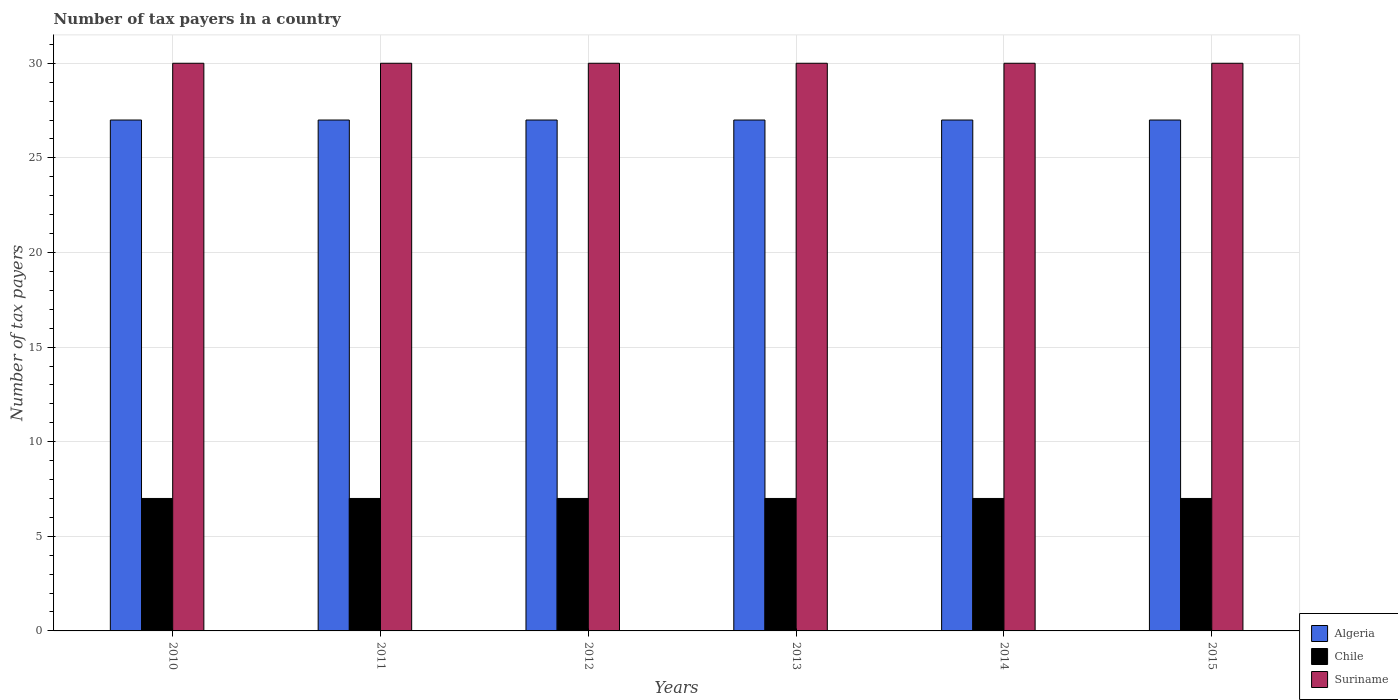In how many cases, is the number of bars for a given year not equal to the number of legend labels?
Ensure brevity in your answer.  0. What is the number of tax payers in in Chile in 2014?
Your answer should be compact. 7. Across all years, what is the maximum number of tax payers in in Chile?
Keep it short and to the point. 7. Across all years, what is the minimum number of tax payers in in Suriname?
Offer a terse response. 30. In which year was the number of tax payers in in Suriname minimum?
Your answer should be very brief. 2010. What is the total number of tax payers in in Chile in the graph?
Give a very brief answer. 42. What is the difference between the number of tax payers in in Chile in 2011 and that in 2014?
Give a very brief answer. 0. What is the difference between the number of tax payers in in Suriname in 2015 and the number of tax payers in in Algeria in 2013?
Provide a succinct answer. 3. In the year 2010, what is the difference between the number of tax payers in in Suriname and number of tax payers in in Chile?
Provide a short and direct response. 23. In how many years, is the number of tax payers in in Algeria greater than 26?
Offer a very short reply. 6. Is the difference between the number of tax payers in in Suriname in 2014 and 2015 greater than the difference between the number of tax payers in in Chile in 2014 and 2015?
Your answer should be compact. No. What is the difference between the highest and the second highest number of tax payers in in Suriname?
Your answer should be compact. 0. What is the difference between the highest and the lowest number of tax payers in in Algeria?
Keep it short and to the point. 0. What does the 1st bar from the left in 2010 represents?
Offer a terse response. Algeria. What does the 1st bar from the right in 2013 represents?
Offer a very short reply. Suriname. How many bars are there?
Offer a terse response. 18. Are all the bars in the graph horizontal?
Provide a short and direct response. No. How many years are there in the graph?
Your response must be concise. 6. What is the difference between two consecutive major ticks on the Y-axis?
Your answer should be very brief. 5. Are the values on the major ticks of Y-axis written in scientific E-notation?
Keep it short and to the point. No. Does the graph contain any zero values?
Your response must be concise. No. Does the graph contain grids?
Your answer should be compact. Yes. How many legend labels are there?
Your answer should be compact. 3. What is the title of the graph?
Make the answer very short. Number of tax payers in a country. What is the label or title of the Y-axis?
Your response must be concise. Number of tax payers. What is the Number of tax payers of Algeria in 2011?
Offer a terse response. 27. What is the Number of tax payers in Suriname in 2011?
Offer a very short reply. 30. What is the Number of tax payers of Chile in 2012?
Ensure brevity in your answer.  7. What is the Number of tax payers in Algeria in 2013?
Your answer should be very brief. 27. What is the Number of tax payers of Algeria in 2014?
Offer a terse response. 27. What is the Number of tax payers in Suriname in 2014?
Your response must be concise. 30. What is the Number of tax payers of Chile in 2015?
Provide a short and direct response. 7. Across all years, what is the maximum Number of tax payers of Suriname?
Keep it short and to the point. 30. Across all years, what is the minimum Number of tax payers of Algeria?
Give a very brief answer. 27. Across all years, what is the minimum Number of tax payers in Chile?
Offer a terse response. 7. What is the total Number of tax payers in Algeria in the graph?
Provide a succinct answer. 162. What is the total Number of tax payers in Suriname in the graph?
Give a very brief answer. 180. What is the difference between the Number of tax payers in Algeria in 2010 and that in 2011?
Offer a very short reply. 0. What is the difference between the Number of tax payers in Suriname in 2010 and that in 2011?
Your answer should be compact. 0. What is the difference between the Number of tax payers of Algeria in 2010 and that in 2012?
Provide a succinct answer. 0. What is the difference between the Number of tax payers of Algeria in 2010 and that in 2013?
Your answer should be compact. 0. What is the difference between the Number of tax payers in Chile in 2010 and that in 2013?
Your response must be concise. 0. What is the difference between the Number of tax payers of Algeria in 2010 and that in 2014?
Offer a terse response. 0. What is the difference between the Number of tax payers in Chile in 2010 and that in 2014?
Your response must be concise. 0. What is the difference between the Number of tax payers of Suriname in 2010 and that in 2015?
Ensure brevity in your answer.  0. What is the difference between the Number of tax payers in Suriname in 2011 and that in 2012?
Make the answer very short. 0. What is the difference between the Number of tax payers of Chile in 2011 and that in 2013?
Make the answer very short. 0. What is the difference between the Number of tax payers of Suriname in 2011 and that in 2014?
Give a very brief answer. 0. What is the difference between the Number of tax payers in Algeria in 2011 and that in 2015?
Give a very brief answer. 0. What is the difference between the Number of tax payers of Suriname in 2011 and that in 2015?
Your answer should be very brief. 0. What is the difference between the Number of tax payers in Algeria in 2012 and that in 2013?
Provide a short and direct response. 0. What is the difference between the Number of tax payers of Suriname in 2012 and that in 2013?
Ensure brevity in your answer.  0. What is the difference between the Number of tax payers in Algeria in 2012 and that in 2014?
Give a very brief answer. 0. What is the difference between the Number of tax payers of Chile in 2012 and that in 2014?
Keep it short and to the point. 0. What is the difference between the Number of tax payers in Suriname in 2012 and that in 2014?
Make the answer very short. 0. What is the difference between the Number of tax payers of Algeria in 2013 and that in 2014?
Give a very brief answer. 0. What is the difference between the Number of tax payers of Algeria in 2013 and that in 2015?
Give a very brief answer. 0. What is the difference between the Number of tax payers of Suriname in 2013 and that in 2015?
Your answer should be very brief. 0. What is the difference between the Number of tax payers of Algeria in 2014 and that in 2015?
Keep it short and to the point. 0. What is the difference between the Number of tax payers of Suriname in 2014 and that in 2015?
Provide a succinct answer. 0. What is the difference between the Number of tax payers in Algeria in 2010 and the Number of tax payers in Chile in 2011?
Ensure brevity in your answer.  20. What is the difference between the Number of tax payers in Algeria in 2010 and the Number of tax payers in Chile in 2012?
Your response must be concise. 20. What is the difference between the Number of tax payers of Algeria in 2010 and the Number of tax payers of Chile in 2013?
Offer a terse response. 20. What is the difference between the Number of tax payers in Chile in 2010 and the Number of tax payers in Suriname in 2015?
Your response must be concise. -23. What is the difference between the Number of tax payers of Algeria in 2011 and the Number of tax payers of Chile in 2012?
Provide a succinct answer. 20. What is the difference between the Number of tax payers in Chile in 2011 and the Number of tax payers in Suriname in 2012?
Offer a very short reply. -23. What is the difference between the Number of tax payers in Algeria in 2011 and the Number of tax payers in Chile in 2013?
Offer a very short reply. 20. What is the difference between the Number of tax payers of Algeria in 2011 and the Number of tax payers of Suriname in 2013?
Give a very brief answer. -3. What is the difference between the Number of tax payers of Algeria in 2011 and the Number of tax payers of Suriname in 2014?
Offer a terse response. -3. What is the difference between the Number of tax payers of Algeria in 2011 and the Number of tax payers of Chile in 2015?
Provide a short and direct response. 20. What is the difference between the Number of tax payers in Algeria in 2012 and the Number of tax payers in Chile in 2013?
Ensure brevity in your answer.  20. What is the difference between the Number of tax payers in Algeria in 2012 and the Number of tax payers in Chile in 2014?
Offer a very short reply. 20. What is the difference between the Number of tax payers of Algeria in 2012 and the Number of tax payers of Suriname in 2014?
Keep it short and to the point. -3. What is the difference between the Number of tax payers of Chile in 2012 and the Number of tax payers of Suriname in 2014?
Provide a short and direct response. -23. What is the difference between the Number of tax payers in Algeria in 2013 and the Number of tax payers in Chile in 2014?
Give a very brief answer. 20. What is the difference between the Number of tax payers in Algeria in 2013 and the Number of tax payers in Suriname in 2014?
Offer a terse response. -3. What is the difference between the Number of tax payers of Chile in 2013 and the Number of tax payers of Suriname in 2014?
Provide a short and direct response. -23. What is the difference between the Number of tax payers in Algeria in 2013 and the Number of tax payers in Suriname in 2015?
Offer a terse response. -3. What is the average Number of tax payers of Chile per year?
Provide a succinct answer. 7. In the year 2010, what is the difference between the Number of tax payers in Chile and Number of tax payers in Suriname?
Give a very brief answer. -23. In the year 2011, what is the difference between the Number of tax payers in Algeria and Number of tax payers in Chile?
Provide a succinct answer. 20. In the year 2011, what is the difference between the Number of tax payers of Chile and Number of tax payers of Suriname?
Provide a succinct answer. -23. In the year 2012, what is the difference between the Number of tax payers of Algeria and Number of tax payers of Chile?
Keep it short and to the point. 20. In the year 2012, what is the difference between the Number of tax payers of Algeria and Number of tax payers of Suriname?
Your answer should be very brief. -3. In the year 2013, what is the difference between the Number of tax payers in Algeria and Number of tax payers in Chile?
Your answer should be very brief. 20. In the year 2013, what is the difference between the Number of tax payers of Chile and Number of tax payers of Suriname?
Offer a terse response. -23. In the year 2014, what is the difference between the Number of tax payers of Algeria and Number of tax payers of Suriname?
Offer a terse response. -3. What is the ratio of the Number of tax payers in Algeria in 2010 to that in 2011?
Provide a short and direct response. 1. What is the ratio of the Number of tax payers in Algeria in 2010 to that in 2014?
Keep it short and to the point. 1. What is the ratio of the Number of tax payers in Suriname in 2010 to that in 2015?
Provide a short and direct response. 1. What is the ratio of the Number of tax payers in Chile in 2011 to that in 2012?
Your answer should be compact. 1. What is the ratio of the Number of tax payers in Suriname in 2011 to that in 2012?
Offer a very short reply. 1. What is the ratio of the Number of tax payers of Algeria in 2011 to that in 2013?
Your response must be concise. 1. What is the ratio of the Number of tax payers in Algeria in 2011 to that in 2014?
Your answer should be very brief. 1. What is the ratio of the Number of tax payers in Algeria in 2011 to that in 2015?
Offer a terse response. 1. What is the ratio of the Number of tax payers in Chile in 2011 to that in 2015?
Ensure brevity in your answer.  1. What is the ratio of the Number of tax payers in Suriname in 2011 to that in 2015?
Your answer should be compact. 1. What is the ratio of the Number of tax payers of Chile in 2012 to that in 2013?
Give a very brief answer. 1. What is the ratio of the Number of tax payers of Suriname in 2012 to that in 2013?
Your answer should be very brief. 1. What is the ratio of the Number of tax payers in Algeria in 2012 to that in 2014?
Your response must be concise. 1. What is the ratio of the Number of tax payers of Chile in 2012 to that in 2014?
Keep it short and to the point. 1. What is the ratio of the Number of tax payers in Suriname in 2012 to that in 2015?
Give a very brief answer. 1. What is the ratio of the Number of tax payers in Algeria in 2013 to that in 2014?
Offer a very short reply. 1. What is the ratio of the Number of tax payers of Chile in 2013 to that in 2014?
Keep it short and to the point. 1. What is the ratio of the Number of tax payers in Suriname in 2013 to that in 2015?
Your answer should be compact. 1. What is the ratio of the Number of tax payers of Algeria in 2014 to that in 2015?
Your answer should be very brief. 1. What is the ratio of the Number of tax payers in Chile in 2014 to that in 2015?
Offer a terse response. 1. What is the ratio of the Number of tax payers of Suriname in 2014 to that in 2015?
Your response must be concise. 1. What is the difference between the highest and the second highest Number of tax payers of Algeria?
Ensure brevity in your answer.  0. What is the difference between the highest and the lowest Number of tax payers in Algeria?
Keep it short and to the point. 0. What is the difference between the highest and the lowest Number of tax payers of Chile?
Give a very brief answer. 0. 